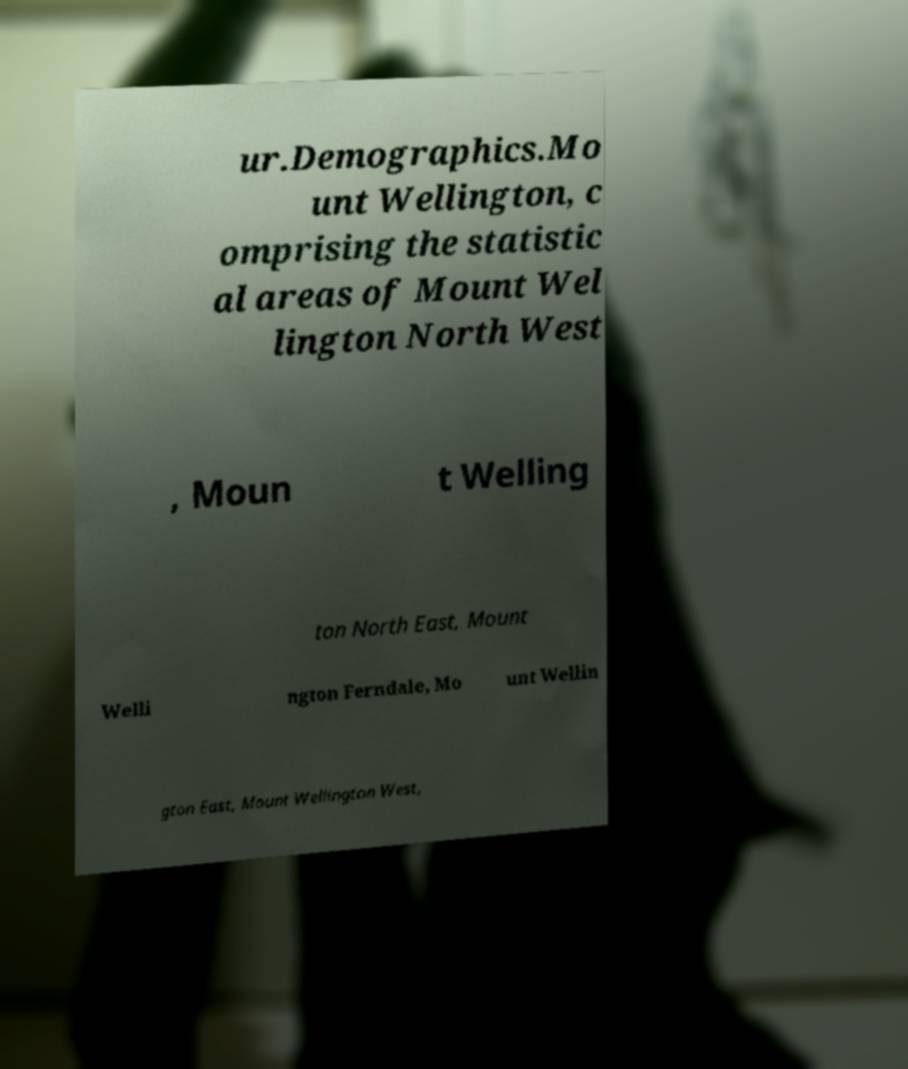What messages or text are displayed in this image? I need them in a readable, typed format. ur.Demographics.Mo unt Wellington, c omprising the statistic al areas of Mount Wel lington North West , Moun t Welling ton North East, Mount Welli ngton Ferndale, Mo unt Wellin gton East, Mount Wellington West, 